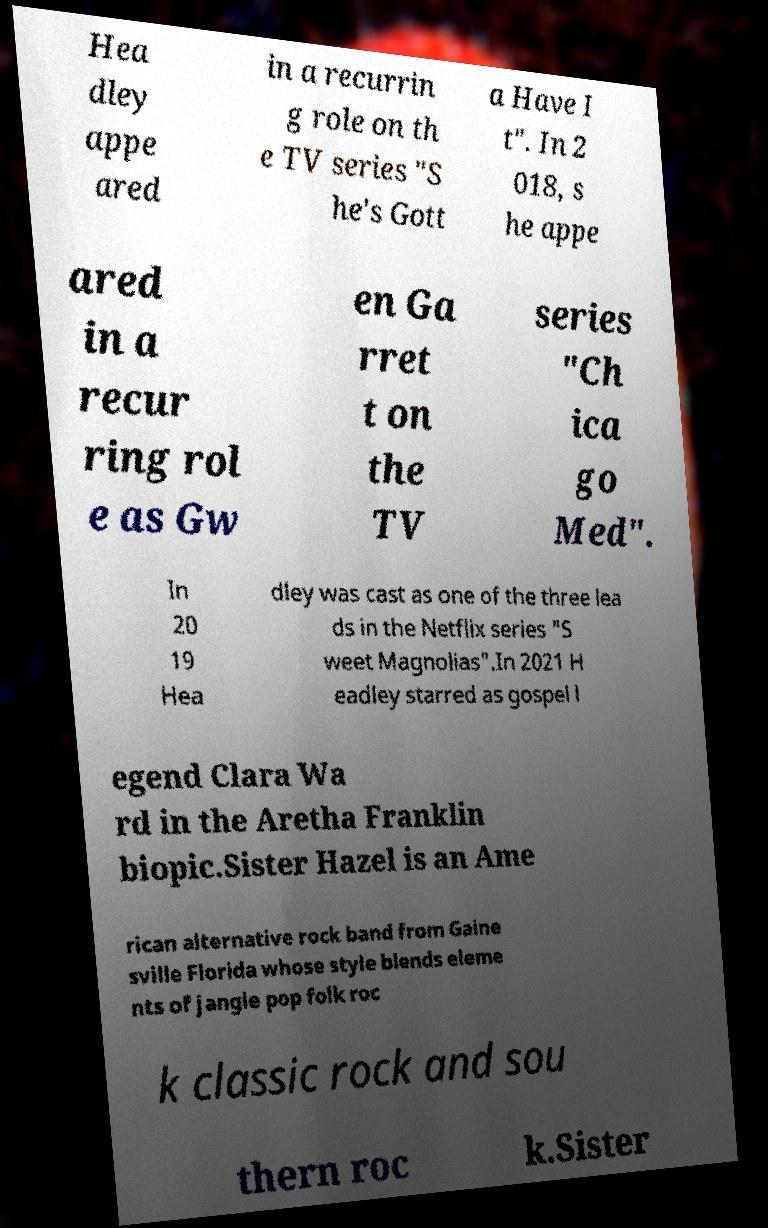Please identify and transcribe the text found in this image. Hea dley appe ared in a recurrin g role on th e TV series "S he's Gott a Have I t". In 2 018, s he appe ared in a recur ring rol e as Gw en Ga rret t on the TV series "Ch ica go Med". In 20 19 Hea dley was cast as one of the three lea ds in the Netflix series "S weet Magnolias".In 2021 H eadley starred as gospel l egend Clara Wa rd in the Aretha Franklin biopic.Sister Hazel is an Ame rican alternative rock band from Gaine sville Florida whose style blends eleme nts of jangle pop folk roc k classic rock and sou thern roc k.Sister 